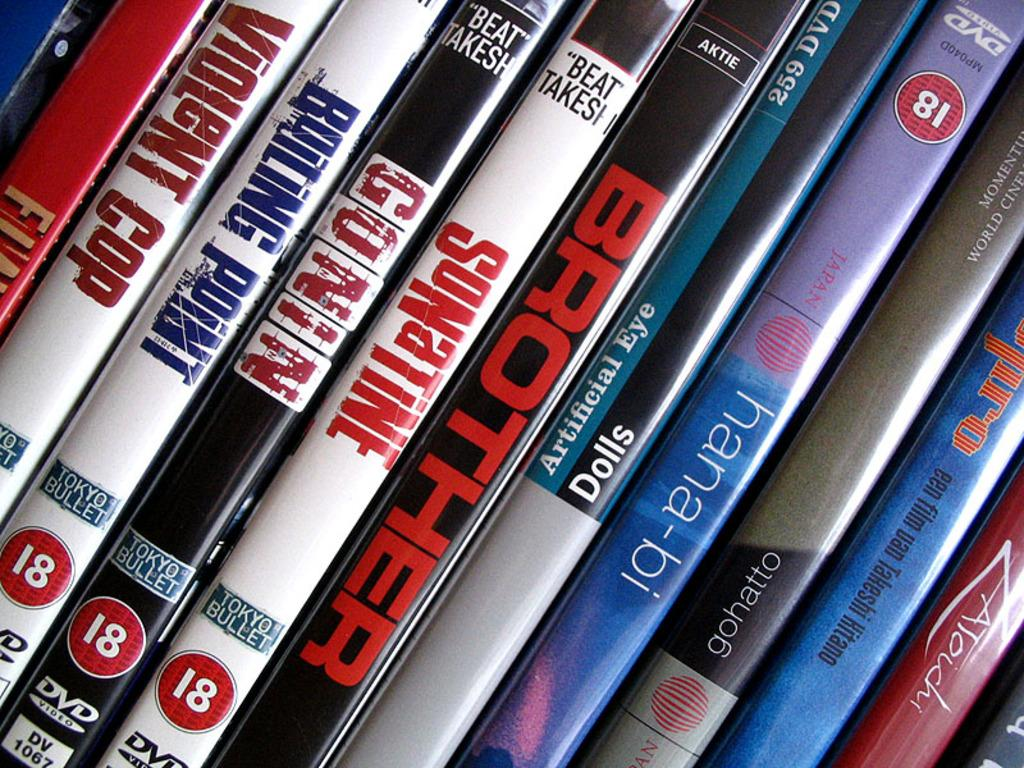<image>
Share a concise interpretation of the image provided. a side view of DVD's of Brother and Conin amomg others. 